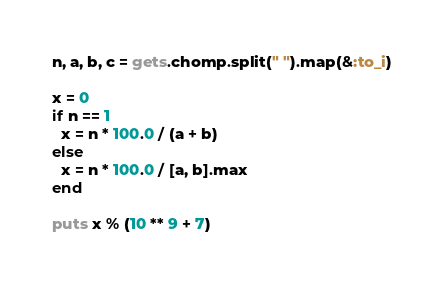Convert code to text. <code><loc_0><loc_0><loc_500><loc_500><_Ruby_>n, a, b, c = gets.chomp.split(" ").map(&:to_i)

x = 0
if n == 1
  x = n * 100.0 / (a + b)
else
  x = n * 100.0 / [a, b].max
end

puts x % (10 ** 9 + 7)
</code> 